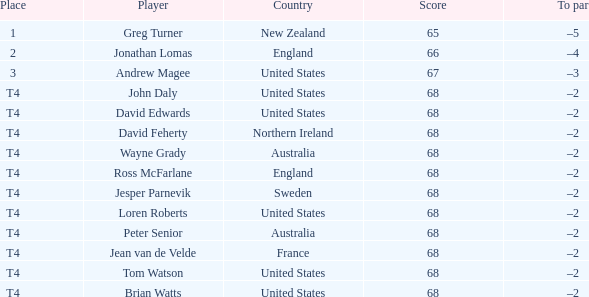Can you provide tom watson's score within the united states? 68.0. 